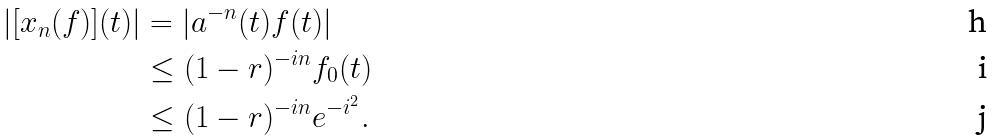Convert formula to latex. <formula><loc_0><loc_0><loc_500><loc_500>| [ x _ { n } ( f ) ] ( t ) | & = | a ^ { - n } ( t ) f ( t ) | \\ & \leq ( 1 - r ) ^ { - i n } f _ { 0 } ( t ) \\ & \leq ( 1 - r ) ^ { - i n } e ^ { - i ^ { 2 } } .</formula> 